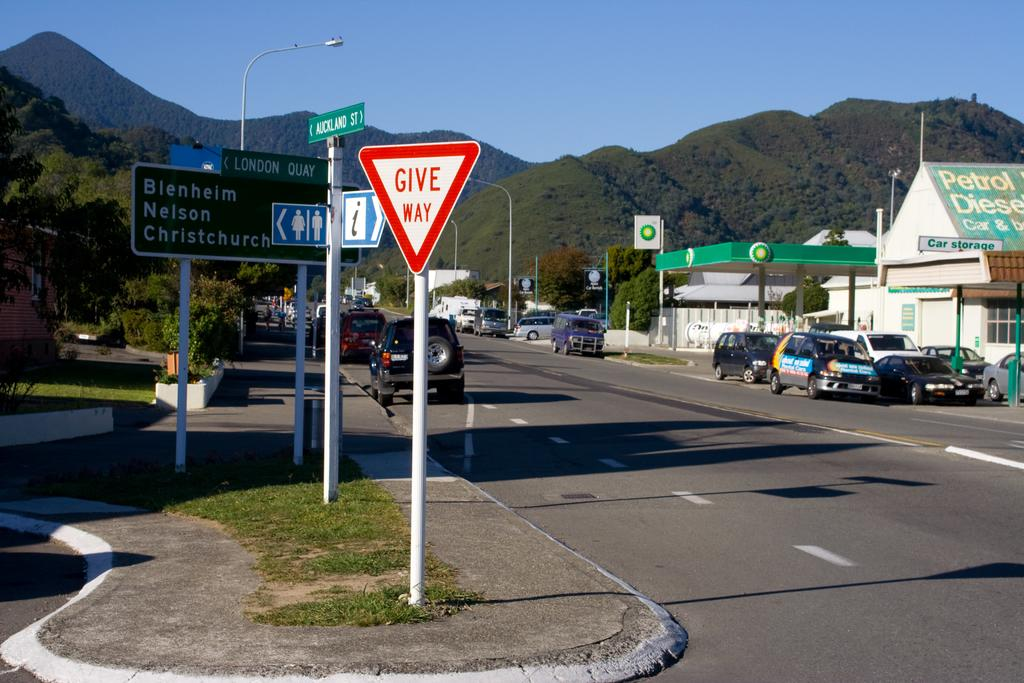<image>
Render a clear and concise summary of the photo. a give way sign that is next to the street 